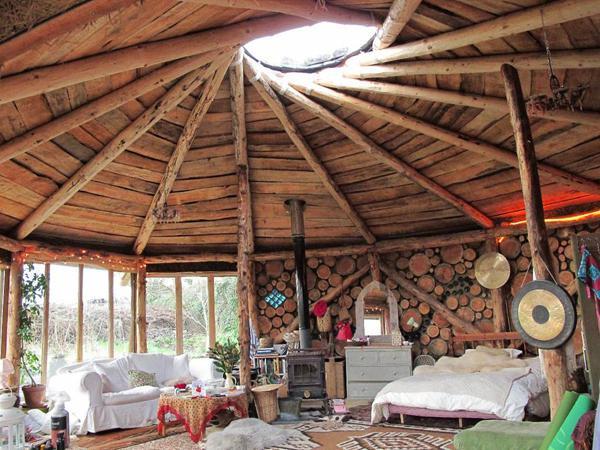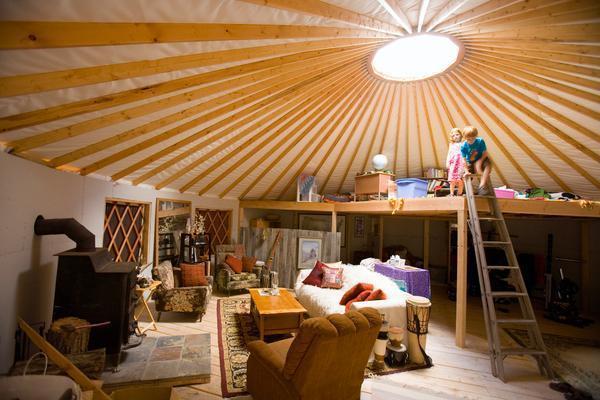The first image is the image on the left, the second image is the image on the right. For the images displayed, is the sentence "A bed sits on the ground floor of the hut in at least one of the images." factually correct? Answer yes or no. Yes. The first image is the image on the left, the second image is the image on the right. Examine the images to the left and right. Is the description "A ladder to a loft is standing at the right in an image of a yurt's interior." accurate? Answer yes or no. Yes. 